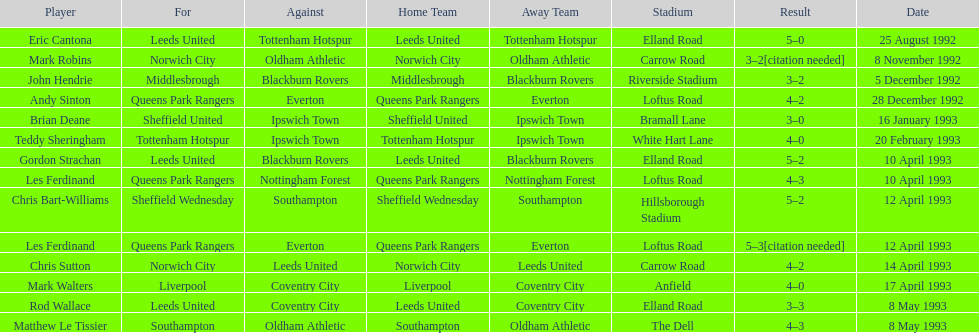Name the players for tottenham hotspur. Teddy Sheringham. 